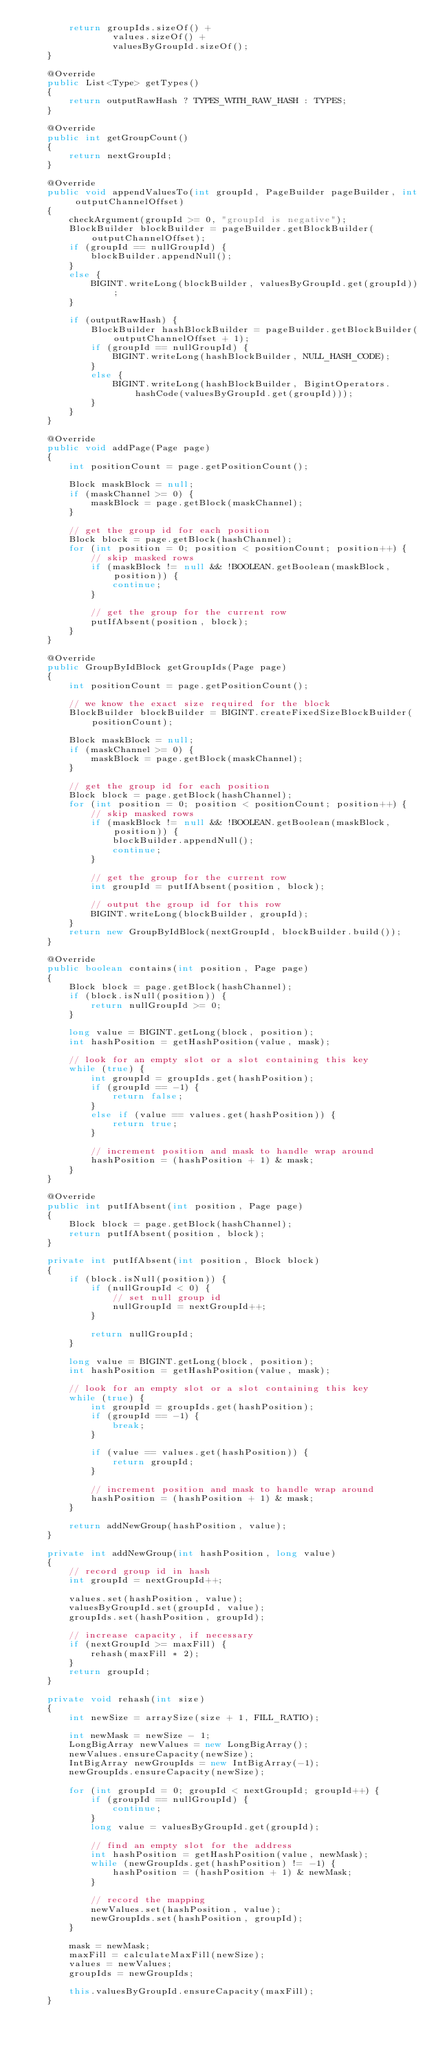Convert code to text. <code><loc_0><loc_0><loc_500><loc_500><_Java_>        return groupIds.sizeOf() +
                values.sizeOf() +
                valuesByGroupId.sizeOf();
    }

    @Override
    public List<Type> getTypes()
    {
        return outputRawHash ? TYPES_WITH_RAW_HASH : TYPES;
    }

    @Override
    public int getGroupCount()
    {
        return nextGroupId;
    }

    @Override
    public void appendValuesTo(int groupId, PageBuilder pageBuilder, int outputChannelOffset)
    {
        checkArgument(groupId >= 0, "groupId is negative");
        BlockBuilder blockBuilder = pageBuilder.getBlockBuilder(outputChannelOffset);
        if (groupId == nullGroupId) {
            blockBuilder.appendNull();
        }
        else {
            BIGINT.writeLong(blockBuilder, valuesByGroupId.get(groupId));
        }

        if (outputRawHash) {
            BlockBuilder hashBlockBuilder = pageBuilder.getBlockBuilder(outputChannelOffset + 1);
            if (groupId == nullGroupId) {
                BIGINT.writeLong(hashBlockBuilder, NULL_HASH_CODE);
            }
            else {
                BIGINT.writeLong(hashBlockBuilder, BigintOperators.hashCode(valuesByGroupId.get(groupId)));
            }
        }
    }

    @Override
    public void addPage(Page page)
    {
        int positionCount = page.getPositionCount();

        Block maskBlock = null;
        if (maskChannel >= 0) {
            maskBlock = page.getBlock(maskChannel);
        }

        // get the group id for each position
        Block block = page.getBlock(hashChannel);
        for (int position = 0; position < positionCount; position++) {
            // skip masked rows
            if (maskBlock != null && !BOOLEAN.getBoolean(maskBlock, position)) {
                continue;
            }

            // get the group for the current row
            putIfAbsent(position, block);
        }
    }

    @Override
    public GroupByIdBlock getGroupIds(Page page)
    {
        int positionCount = page.getPositionCount();

        // we know the exact size required for the block
        BlockBuilder blockBuilder = BIGINT.createFixedSizeBlockBuilder(positionCount);

        Block maskBlock = null;
        if (maskChannel >= 0) {
            maskBlock = page.getBlock(maskChannel);
        }

        // get the group id for each position
        Block block = page.getBlock(hashChannel);
        for (int position = 0; position < positionCount; position++) {
            // skip masked rows
            if (maskBlock != null && !BOOLEAN.getBoolean(maskBlock, position)) {
                blockBuilder.appendNull();
                continue;
            }

            // get the group for the current row
            int groupId = putIfAbsent(position, block);

            // output the group id for this row
            BIGINT.writeLong(blockBuilder, groupId);
        }
        return new GroupByIdBlock(nextGroupId, blockBuilder.build());
    }

    @Override
    public boolean contains(int position, Page page)
    {
        Block block = page.getBlock(hashChannel);
        if (block.isNull(position)) {
            return nullGroupId >= 0;
        }

        long value = BIGINT.getLong(block, position);
        int hashPosition = getHashPosition(value, mask);

        // look for an empty slot or a slot containing this key
        while (true) {
            int groupId = groupIds.get(hashPosition);
            if (groupId == -1) {
                return false;
            }
            else if (value == values.get(hashPosition)) {
                return true;
            }

            // increment position and mask to handle wrap around
            hashPosition = (hashPosition + 1) & mask;
        }
    }

    @Override
    public int putIfAbsent(int position, Page page)
    {
        Block block = page.getBlock(hashChannel);
        return putIfAbsent(position, block);
    }

    private int putIfAbsent(int position, Block block)
    {
        if (block.isNull(position)) {
            if (nullGroupId < 0) {
                // set null group id
                nullGroupId = nextGroupId++;
            }

            return nullGroupId;
        }

        long value = BIGINT.getLong(block, position);
        int hashPosition = getHashPosition(value, mask);

        // look for an empty slot or a slot containing this key
        while (true) {
            int groupId = groupIds.get(hashPosition);
            if (groupId == -1) {
                break;
            }

            if (value == values.get(hashPosition)) {
                return groupId;
            }

            // increment position and mask to handle wrap around
            hashPosition = (hashPosition + 1) & mask;
        }

        return addNewGroup(hashPosition, value);
    }

    private int addNewGroup(int hashPosition, long value)
    {
        // record group id in hash
        int groupId = nextGroupId++;

        values.set(hashPosition, value);
        valuesByGroupId.set(groupId, value);
        groupIds.set(hashPosition, groupId);

        // increase capacity, if necessary
        if (nextGroupId >= maxFill) {
            rehash(maxFill * 2);
        }
        return groupId;
    }

    private void rehash(int size)
    {
        int newSize = arraySize(size + 1, FILL_RATIO);

        int newMask = newSize - 1;
        LongBigArray newValues = new LongBigArray();
        newValues.ensureCapacity(newSize);
        IntBigArray newGroupIds = new IntBigArray(-1);
        newGroupIds.ensureCapacity(newSize);

        for (int groupId = 0; groupId < nextGroupId; groupId++) {
            if (groupId == nullGroupId) {
                continue;
            }
            long value = valuesByGroupId.get(groupId);

            // find an empty slot for the address
            int hashPosition = getHashPosition(value, newMask);
            while (newGroupIds.get(hashPosition) != -1) {
                hashPosition = (hashPosition + 1) & newMask;
            }

            // record the mapping
            newValues.set(hashPosition, value);
            newGroupIds.set(hashPosition, groupId);
        }

        mask = newMask;
        maxFill = calculateMaxFill(newSize);
        values = newValues;
        groupIds = newGroupIds;

        this.valuesByGroupId.ensureCapacity(maxFill);
    }
</code> 